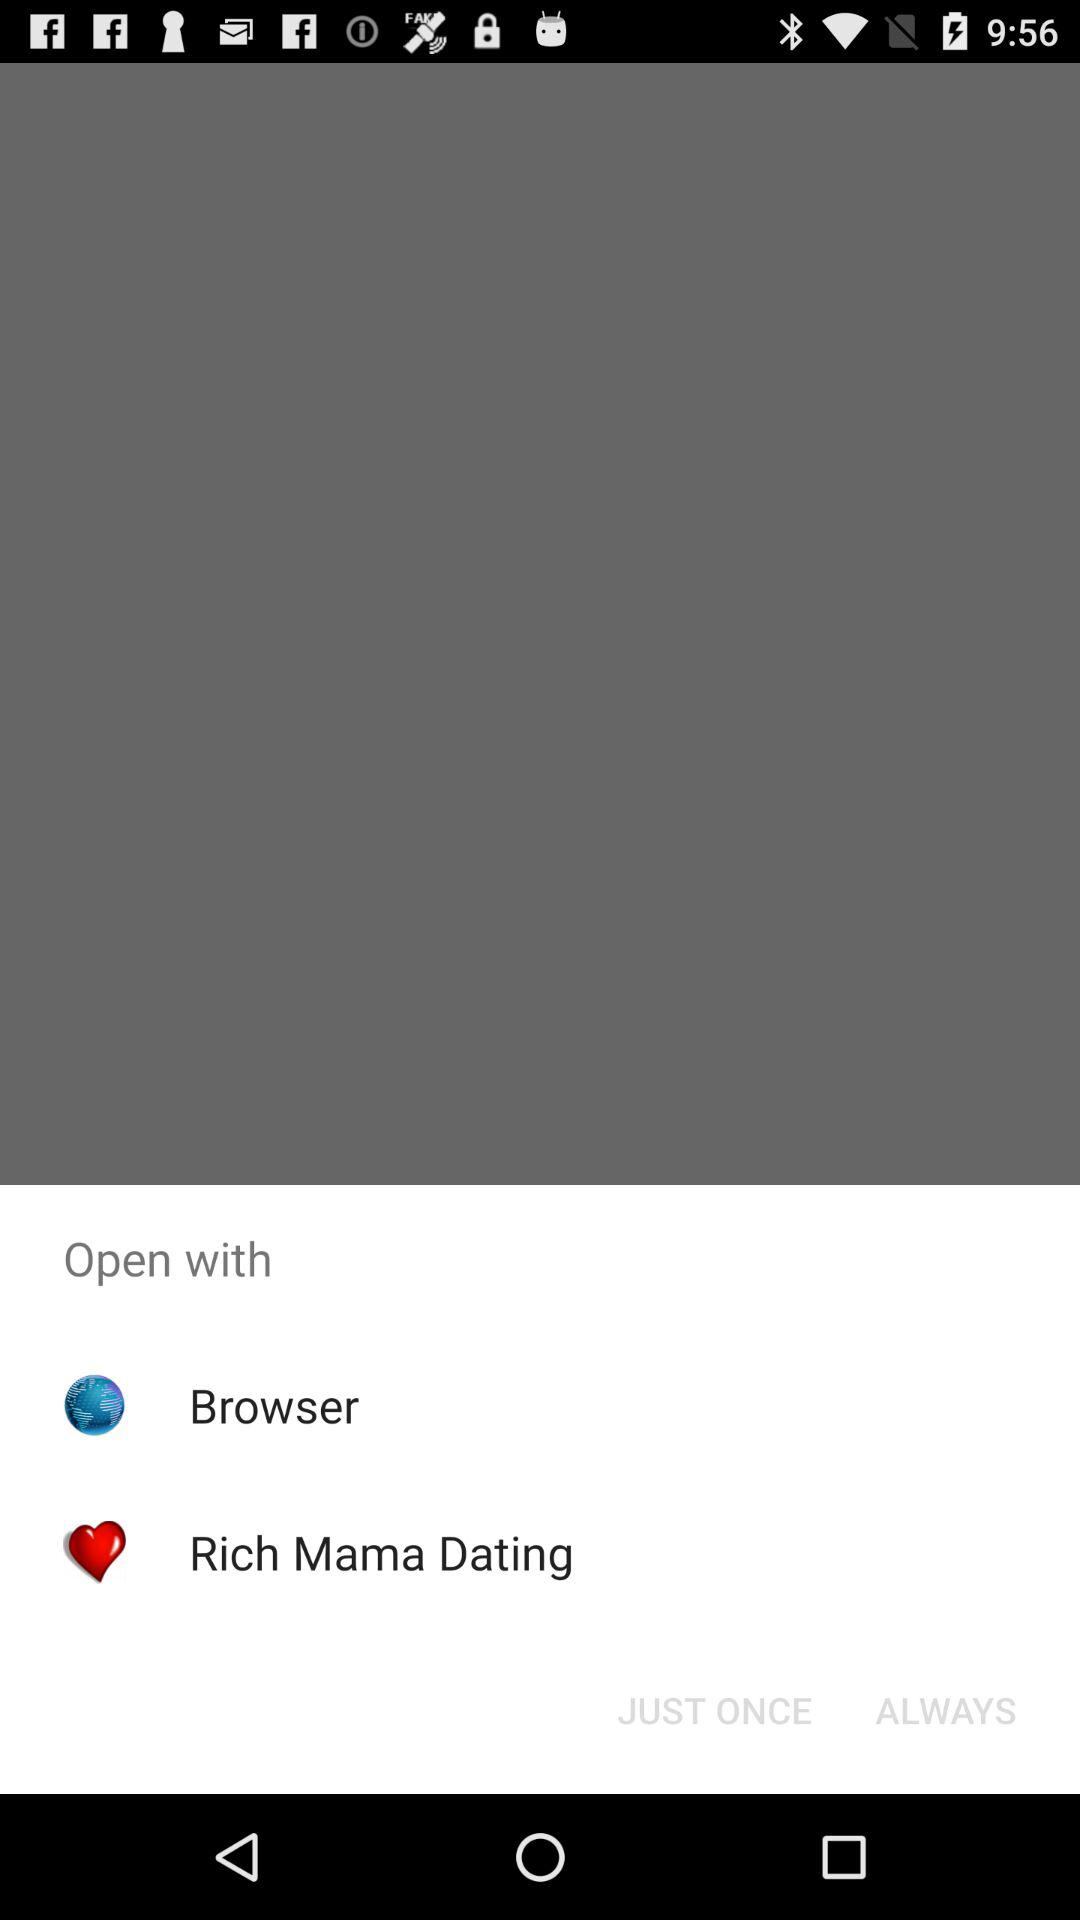What options are given here to open with? The options are: "Browser" and "Rich Mama Dating". 